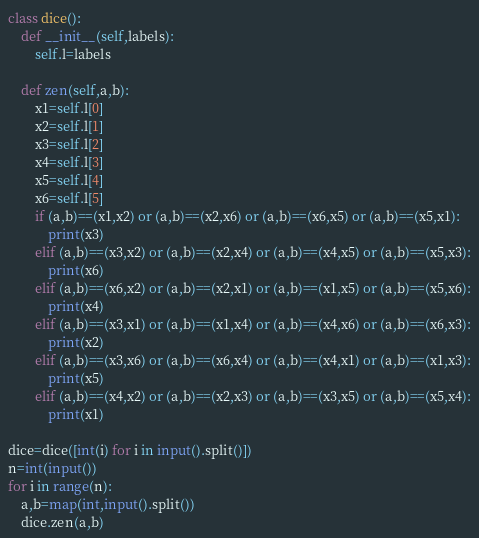Convert code to text. <code><loc_0><loc_0><loc_500><loc_500><_Python_>class dice():
    def __init__(self,labels):
        self.l=labels

    def zen(self,a,b):
        x1=self.l[0]
        x2=self.l[1]
        x3=self.l[2]
        x4=self.l[3]
        x5=self.l[4]
        x6=self.l[5]
        if (a,b)==(x1,x2) or (a,b)==(x2,x6) or (a,b)==(x6,x5) or (a,b)==(x5,x1):
            print(x3)
        elif (a,b)==(x3,x2) or (a,b)==(x2,x4) or (a,b)==(x4,x5) or (a,b)==(x5,x3):
            print(x6)
        elif (a,b)==(x6,x2) or (a,b)==(x2,x1) or (a,b)==(x1,x5) or (a,b)==(x5,x6):
            print(x4)
        elif (a,b)==(x3,x1) or (a,b)==(x1,x4) or (a,b)==(x4,x6) or (a,b)==(x6,x3):
            print(x2)
        elif (a,b)==(x3,x6) or (a,b)==(x6,x4) or (a,b)==(x4,x1) or (a,b)==(x1,x3):
            print(x5)
        elif (a,b)==(x4,x2) or (a,b)==(x2,x3) or (a,b)==(x3,x5) or (a,b)==(x5,x4):
            print(x1)

dice=dice([int(i) for i in input().split()])
n=int(input())
for i in range(n):
    a,b=map(int,input().split())
    dice.zen(a,b)

</code> 